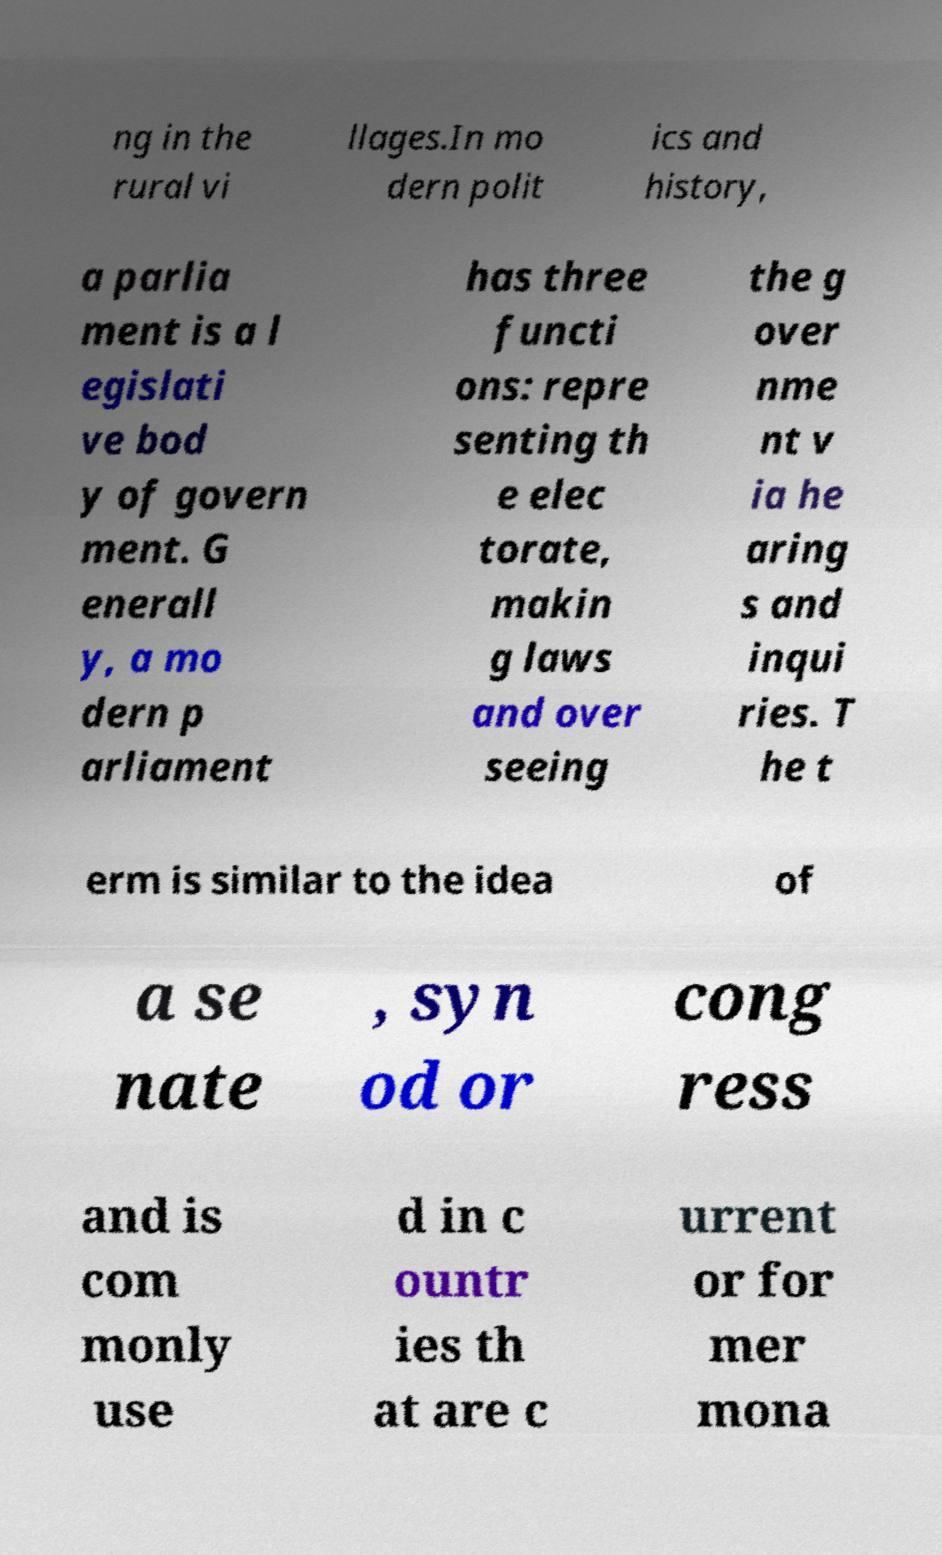Could you assist in decoding the text presented in this image and type it out clearly? ng in the rural vi llages.In mo dern polit ics and history, a parlia ment is a l egislati ve bod y of govern ment. G enerall y, a mo dern p arliament has three functi ons: repre senting th e elec torate, makin g laws and over seeing the g over nme nt v ia he aring s and inqui ries. T he t erm is similar to the idea of a se nate , syn od or cong ress and is com monly use d in c ountr ies th at are c urrent or for mer mona 